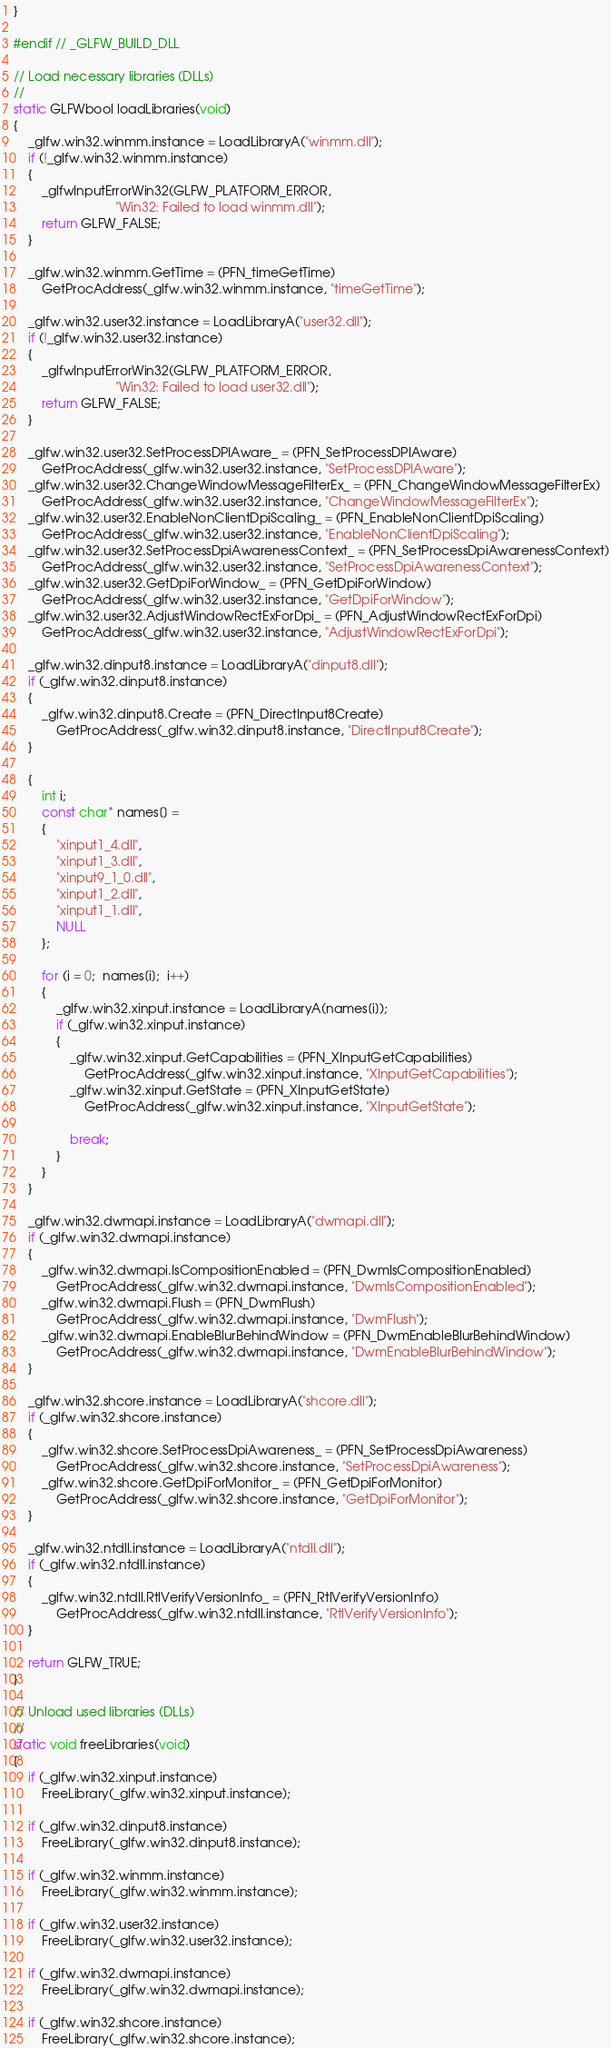Convert code to text. <code><loc_0><loc_0><loc_500><loc_500><_C_>}

#endif // _GLFW_BUILD_DLL

// Load necessary libraries (DLLs)
//
static GLFWbool loadLibraries(void)
{
    _glfw.win32.winmm.instance = LoadLibraryA("winmm.dll");
    if (!_glfw.win32.winmm.instance)
    {
        _glfwInputErrorWin32(GLFW_PLATFORM_ERROR,
                             "Win32: Failed to load winmm.dll");
        return GLFW_FALSE;
    }

    _glfw.win32.winmm.GetTime = (PFN_timeGetTime)
        GetProcAddress(_glfw.win32.winmm.instance, "timeGetTime");

    _glfw.win32.user32.instance = LoadLibraryA("user32.dll");
    if (!_glfw.win32.user32.instance)
    {
        _glfwInputErrorWin32(GLFW_PLATFORM_ERROR,
                             "Win32: Failed to load user32.dll");
        return GLFW_FALSE;
    }

    _glfw.win32.user32.SetProcessDPIAware_ = (PFN_SetProcessDPIAware)
        GetProcAddress(_glfw.win32.user32.instance, "SetProcessDPIAware");
    _glfw.win32.user32.ChangeWindowMessageFilterEx_ = (PFN_ChangeWindowMessageFilterEx)
        GetProcAddress(_glfw.win32.user32.instance, "ChangeWindowMessageFilterEx");
    _glfw.win32.user32.EnableNonClientDpiScaling_ = (PFN_EnableNonClientDpiScaling)
        GetProcAddress(_glfw.win32.user32.instance, "EnableNonClientDpiScaling");
    _glfw.win32.user32.SetProcessDpiAwarenessContext_ = (PFN_SetProcessDpiAwarenessContext)
        GetProcAddress(_glfw.win32.user32.instance, "SetProcessDpiAwarenessContext");
    _glfw.win32.user32.GetDpiForWindow_ = (PFN_GetDpiForWindow)
        GetProcAddress(_glfw.win32.user32.instance, "GetDpiForWindow");
    _glfw.win32.user32.AdjustWindowRectExForDpi_ = (PFN_AdjustWindowRectExForDpi)
        GetProcAddress(_glfw.win32.user32.instance, "AdjustWindowRectExForDpi");

    _glfw.win32.dinput8.instance = LoadLibraryA("dinput8.dll");
    if (_glfw.win32.dinput8.instance)
    {
        _glfw.win32.dinput8.Create = (PFN_DirectInput8Create)
            GetProcAddress(_glfw.win32.dinput8.instance, "DirectInput8Create");
    }

    {
        int i;
        const char* names[] =
        {
            "xinput1_4.dll",
            "xinput1_3.dll",
            "xinput9_1_0.dll",
            "xinput1_2.dll",
            "xinput1_1.dll",
            NULL
        };

        for (i = 0;  names[i];  i++)
        {
            _glfw.win32.xinput.instance = LoadLibraryA(names[i]);
            if (_glfw.win32.xinput.instance)
            {
                _glfw.win32.xinput.GetCapabilities = (PFN_XInputGetCapabilities)
                    GetProcAddress(_glfw.win32.xinput.instance, "XInputGetCapabilities");
                _glfw.win32.xinput.GetState = (PFN_XInputGetState)
                    GetProcAddress(_glfw.win32.xinput.instance, "XInputGetState");

                break;
            }
        }
    }

    _glfw.win32.dwmapi.instance = LoadLibraryA("dwmapi.dll");
    if (_glfw.win32.dwmapi.instance)
    {
        _glfw.win32.dwmapi.IsCompositionEnabled = (PFN_DwmIsCompositionEnabled)
            GetProcAddress(_glfw.win32.dwmapi.instance, "DwmIsCompositionEnabled");
        _glfw.win32.dwmapi.Flush = (PFN_DwmFlush)
            GetProcAddress(_glfw.win32.dwmapi.instance, "DwmFlush");
        _glfw.win32.dwmapi.EnableBlurBehindWindow = (PFN_DwmEnableBlurBehindWindow)
            GetProcAddress(_glfw.win32.dwmapi.instance, "DwmEnableBlurBehindWindow");
    }

    _glfw.win32.shcore.instance = LoadLibraryA("shcore.dll");
    if (_glfw.win32.shcore.instance)
    {
        _glfw.win32.shcore.SetProcessDpiAwareness_ = (PFN_SetProcessDpiAwareness)
            GetProcAddress(_glfw.win32.shcore.instance, "SetProcessDpiAwareness");
        _glfw.win32.shcore.GetDpiForMonitor_ = (PFN_GetDpiForMonitor)
            GetProcAddress(_glfw.win32.shcore.instance, "GetDpiForMonitor");
    }

    _glfw.win32.ntdll.instance = LoadLibraryA("ntdll.dll");
    if (_glfw.win32.ntdll.instance)
    {
        _glfw.win32.ntdll.RtlVerifyVersionInfo_ = (PFN_RtlVerifyVersionInfo)
            GetProcAddress(_glfw.win32.ntdll.instance, "RtlVerifyVersionInfo");
    }

    return GLFW_TRUE;
}

// Unload used libraries (DLLs)
//
static void freeLibraries(void)
{
    if (_glfw.win32.xinput.instance)
        FreeLibrary(_glfw.win32.xinput.instance);

    if (_glfw.win32.dinput8.instance)
        FreeLibrary(_glfw.win32.dinput8.instance);

    if (_glfw.win32.winmm.instance)
        FreeLibrary(_glfw.win32.winmm.instance);

    if (_glfw.win32.user32.instance)
        FreeLibrary(_glfw.win32.user32.instance);

    if (_glfw.win32.dwmapi.instance)
        FreeLibrary(_glfw.win32.dwmapi.instance);

    if (_glfw.win32.shcore.instance)
        FreeLibrary(_glfw.win32.shcore.instance);
</code> 